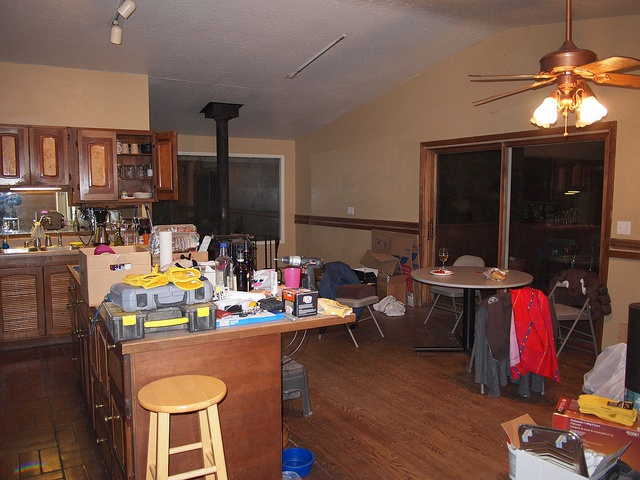Describe the objects in this image and their specific colors. I can see chair in gray, black, brown, and maroon tones, chair in gray, tan, and brown tones, dining table in gray, black, and brown tones, chair in gray and black tones, and chair in gray, black, and maroon tones in this image. 